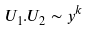Convert formula to latex. <formula><loc_0><loc_0><loc_500><loc_500>U _ { 1 } . U _ { 2 } \sim y ^ { k }</formula> 